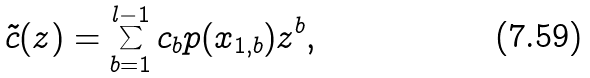Convert formula to latex. <formula><loc_0><loc_0><loc_500><loc_500>\tilde { c } ( z ) = \sum _ { b = 1 } ^ { l - 1 } c _ { b } p ( { x } _ { 1 , b } ) z ^ { b } ,</formula> 